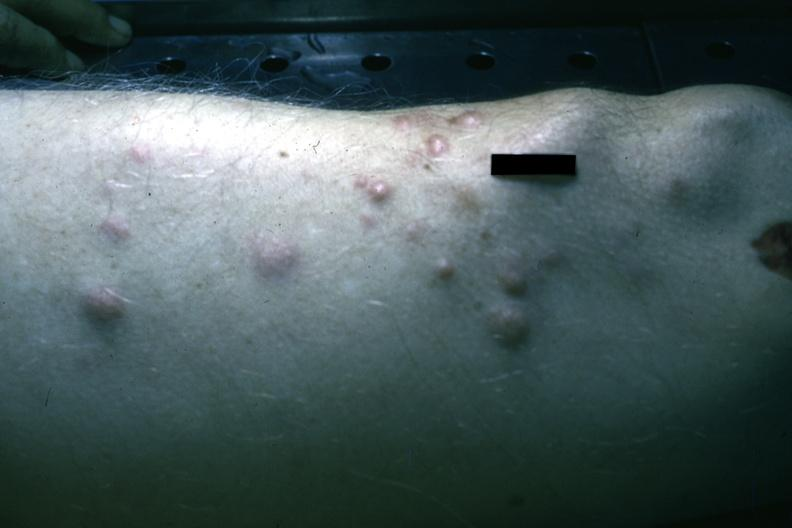does this image show multiple nodular lesions infiltrating neoplastic plasma cells?
Answer the question using a single word or phrase. Yes 